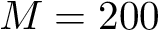<formula> <loc_0><loc_0><loc_500><loc_500>M = 2 0 0</formula> 